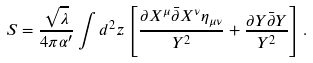<formula> <loc_0><loc_0><loc_500><loc_500>S = \frac { \sqrt { \lambda } } { 4 \pi \alpha ^ { \prime } } \int d ^ { 2 } z \left [ \frac { \partial X ^ { \mu } \bar { \partial } X ^ { \nu } \eta _ { \mu \nu } } { Y ^ { 2 } } + \frac { \partial Y \bar { \partial } Y } { Y ^ { 2 } } \right ] .</formula> 